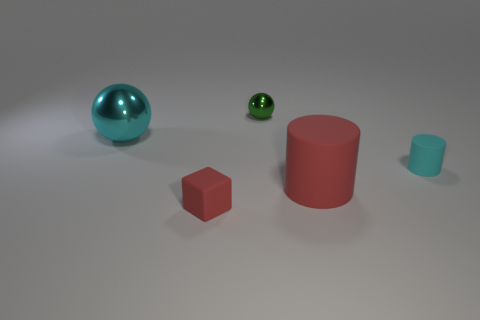Add 3 green metal things. How many objects exist? 8 Subtract all cylinders. How many objects are left? 3 Add 2 tiny red things. How many tiny red things are left? 3 Add 3 tiny yellow matte blocks. How many tiny yellow matte blocks exist? 3 Subtract 0 purple blocks. How many objects are left? 5 Subtract all cyan spheres. Subtract all big red cylinders. How many objects are left? 3 